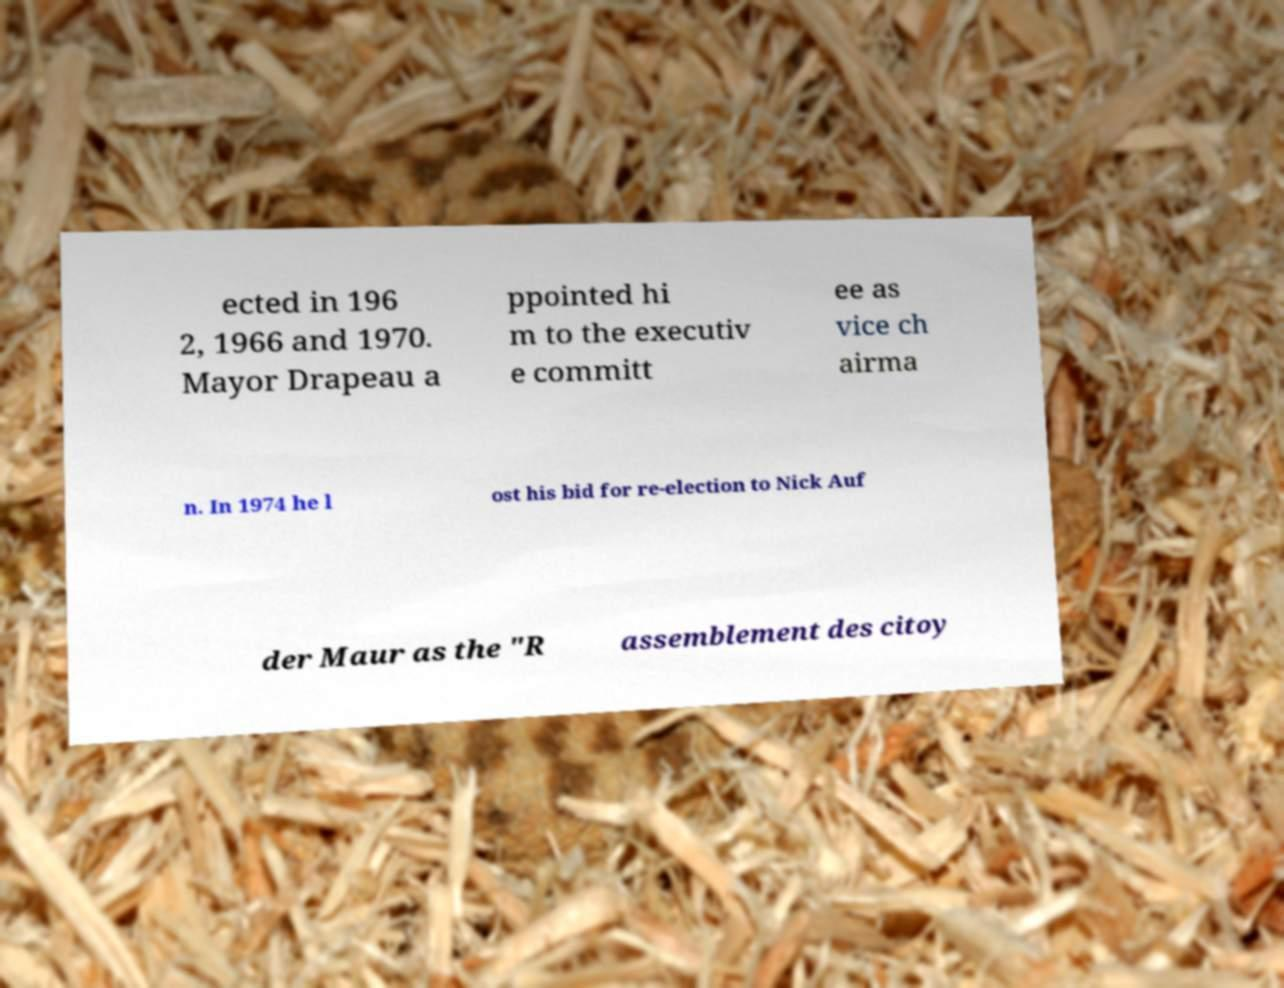Could you extract and type out the text from this image? ected in 196 2, 1966 and 1970. Mayor Drapeau a ppointed hi m to the executiv e committ ee as vice ch airma n. In 1974 he l ost his bid for re-election to Nick Auf der Maur as the "R assemblement des citoy 